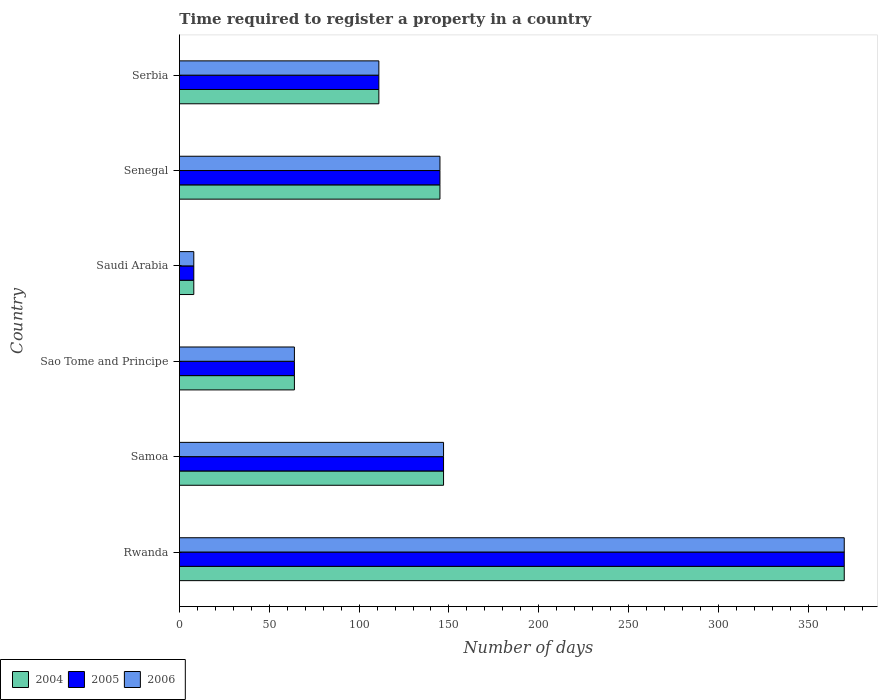Are the number of bars per tick equal to the number of legend labels?
Offer a very short reply. Yes. How many bars are there on the 6th tick from the top?
Provide a short and direct response. 3. How many bars are there on the 6th tick from the bottom?
Offer a terse response. 3. What is the label of the 5th group of bars from the top?
Keep it short and to the point. Samoa. Across all countries, what is the maximum number of days required to register a property in 2004?
Ensure brevity in your answer.  370. In which country was the number of days required to register a property in 2006 maximum?
Give a very brief answer. Rwanda. In which country was the number of days required to register a property in 2004 minimum?
Ensure brevity in your answer.  Saudi Arabia. What is the total number of days required to register a property in 2004 in the graph?
Your answer should be compact. 845. What is the difference between the number of days required to register a property in 2006 in Rwanda and that in Samoa?
Your answer should be very brief. 223. What is the difference between the number of days required to register a property in 2004 in Serbia and the number of days required to register a property in 2006 in Sao Tome and Principe?
Provide a succinct answer. 47. What is the average number of days required to register a property in 2004 per country?
Keep it short and to the point. 140.83. What is the difference between the number of days required to register a property in 2004 and number of days required to register a property in 2006 in Senegal?
Provide a short and direct response. 0. What is the ratio of the number of days required to register a property in 2005 in Saudi Arabia to that in Serbia?
Offer a terse response. 0.07. Is the number of days required to register a property in 2004 in Samoa less than that in Saudi Arabia?
Offer a terse response. No. What is the difference between the highest and the second highest number of days required to register a property in 2004?
Provide a short and direct response. 223. What is the difference between the highest and the lowest number of days required to register a property in 2004?
Offer a terse response. 362. In how many countries, is the number of days required to register a property in 2004 greater than the average number of days required to register a property in 2004 taken over all countries?
Provide a succinct answer. 3. Is the sum of the number of days required to register a property in 2004 in Rwanda and Saudi Arabia greater than the maximum number of days required to register a property in 2006 across all countries?
Make the answer very short. Yes. What does the 2nd bar from the top in Samoa represents?
Provide a short and direct response. 2005. What does the 2nd bar from the bottom in Saudi Arabia represents?
Give a very brief answer. 2005. How many bars are there?
Ensure brevity in your answer.  18. Are all the bars in the graph horizontal?
Give a very brief answer. Yes. What is the difference between two consecutive major ticks on the X-axis?
Your answer should be very brief. 50. Are the values on the major ticks of X-axis written in scientific E-notation?
Offer a terse response. No. Does the graph contain any zero values?
Offer a very short reply. No. Does the graph contain grids?
Keep it short and to the point. No. How are the legend labels stacked?
Keep it short and to the point. Horizontal. What is the title of the graph?
Give a very brief answer. Time required to register a property in a country. What is the label or title of the X-axis?
Provide a succinct answer. Number of days. What is the label or title of the Y-axis?
Give a very brief answer. Country. What is the Number of days in 2004 in Rwanda?
Your response must be concise. 370. What is the Number of days in 2005 in Rwanda?
Your answer should be compact. 370. What is the Number of days of 2006 in Rwanda?
Offer a terse response. 370. What is the Number of days of 2004 in Samoa?
Give a very brief answer. 147. What is the Number of days of 2005 in Samoa?
Give a very brief answer. 147. What is the Number of days of 2006 in Samoa?
Make the answer very short. 147. What is the Number of days of 2005 in Sao Tome and Principe?
Your response must be concise. 64. What is the Number of days of 2006 in Sao Tome and Principe?
Offer a very short reply. 64. What is the Number of days in 2005 in Saudi Arabia?
Provide a succinct answer. 8. What is the Number of days of 2004 in Senegal?
Give a very brief answer. 145. What is the Number of days in 2005 in Senegal?
Your response must be concise. 145. What is the Number of days of 2006 in Senegal?
Your answer should be very brief. 145. What is the Number of days of 2004 in Serbia?
Offer a terse response. 111. What is the Number of days in 2005 in Serbia?
Ensure brevity in your answer.  111. What is the Number of days of 2006 in Serbia?
Your response must be concise. 111. Across all countries, what is the maximum Number of days in 2004?
Make the answer very short. 370. Across all countries, what is the maximum Number of days in 2005?
Your answer should be compact. 370. Across all countries, what is the maximum Number of days in 2006?
Your answer should be very brief. 370. Across all countries, what is the minimum Number of days in 2004?
Keep it short and to the point. 8. Across all countries, what is the minimum Number of days of 2006?
Provide a short and direct response. 8. What is the total Number of days of 2004 in the graph?
Your response must be concise. 845. What is the total Number of days of 2005 in the graph?
Your response must be concise. 845. What is the total Number of days of 2006 in the graph?
Offer a terse response. 845. What is the difference between the Number of days in 2004 in Rwanda and that in Samoa?
Ensure brevity in your answer.  223. What is the difference between the Number of days in 2005 in Rwanda and that in Samoa?
Make the answer very short. 223. What is the difference between the Number of days in 2006 in Rwanda and that in Samoa?
Provide a succinct answer. 223. What is the difference between the Number of days in 2004 in Rwanda and that in Sao Tome and Principe?
Keep it short and to the point. 306. What is the difference between the Number of days of 2005 in Rwanda and that in Sao Tome and Principe?
Your answer should be compact. 306. What is the difference between the Number of days of 2006 in Rwanda and that in Sao Tome and Principe?
Provide a short and direct response. 306. What is the difference between the Number of days of 2004 in Rwanda and that in Saudi Arabia?
Offer a very short reply. 362. What is the difference between the Number of days in 2005 in Rwanda and that in Saudi Arabia?
Offer a terse response. 362. What is the difference between the Number of days in 2006 in Rwanda and that in Saudi Arabia?
Offer a very short reply. 362. What is the difference between the Number of days in 2004 in Rwanda and that in Senegal?
Make the answer very short. 225. What is the difference between the Number of days of 2005 in Rwanda and that in Senegal?
Make the answer very short. 225. What is the difference between the Number of days in 2006 in Rwanda and that in Senegal?
Your answer should be compact. 225. What is the difference between the Number of days of 2004 in Rwanda and that in Serbia?
Make the answer very short. 259. What is the difference between the Number of days in 2005 in Rwanda and that in Serbia?
Make the answer very short. 259. What is the difference between the Number of days of 2006 in Rwanda and that in Serbia?
Give a very brief answer. 259. What is the difference between the Number of days in 2004 in Samoa and that in Sao Tome and Principe?
Your answer should be compact. 83. What is the difference between the Number of days of 2004 in Samoa and that in Saudi Arabia?
Make the answer very short. 139. What is the difference between the Number of days in 2005 in Samoa and that in Saudi Arabia?
Ensure brevity in your answer.  139. What is the difference between the Number of days of 2006 in Samoa and that in Saudi Arabia?
Your answer should be compact. 139. What is the difference between the Number of days of 2004 in Samoa and that in Senegal?
Offer a terse response. 2. What is the difference between the Number of days of 2005 in Samoa and that in Senegal?
Ensure brevity in your answer.  2. What is the difference between the Number of days of 2006 in Samoa and that in Senegal?
Make the answer very short. 2. What is the difference between the Number of days of 2004 in Samoa and that in Serbia?
Ensure brevity in your answer.  36. What is the difference between the Number of days in 2005 in Samoa and that in Serbia?
Make the answer very short. 36. What is the difference between the Number of days in 2006 in Samoa and that in Serbia?
Your response must be concise. 36. What is the difference between the Number of days of 2004 in Sao Tome and Principe and that in Saudi Arabia?
Your response must be concise. 56. What is the difference between the Number of days in 2005 in Sao Tome and Principe and that in Saudi Arabia?
Your answer should be compact. 56. What is the difference between the Number of days of 2004 in Sao Tome and Principe and that in Senegal?
Give a very brief answer. -81. What is the difference between the Number of days of 2005 in Sao Tome and Principe and that in Senegal?
Make the answer very short. -81. What is the difference between the Number of days in 2006 in Sao Tome and Principe and that in Senegal?
Your answer should be compact. -81. What is the difference between the Number of days in 2004 in Sao Tome and Principe and that in Serbia?
Keep it short and to the point. -47. What is the difference between the Number of days in 2005 in Sao Tome and Principe and that in Serbia?
Offer a terse response. -47. What is the difference between the Number of days in 2006 in Sao Tome and Principe and that in Serbia?
Keep it short and to the point. -47. What is the difference between the Number of days of 2004 in Saudi Arabia and that in Senegal?
Provide a succinct answer. -137. What is the difference between the Number of days of 2005 in Saudi Arabia and that in Senegal?
Ensure brevity in your answer.  -137. What is the difference between the Number of days in 2006 in Saudi Arabia and that in Senegal?
Your answer should be compact. -137. What is the difference between the Number of days of 2004 in Saudi Arabia and that in Serbia?
Offer a terse response. -103. What is the difference between the Number of days in 2005 in Saudi Arabia and that in Serbia?
Give a very brief answer. -103. What is the difference between the Number of days in 2006 in Saudi Arabia and that in Serbia?
Offer a terse response. -103. What is the difference between the Number of days of 2004 in Rwanda and the Number of days of 2005 in Samoa?
Offer a terse response. 223. What is the difference between the Number of days of 2004 in Rwanda and the Number of days of 2006 in Samoa?
Provide a succinct answer. 223. What is the difference between the Number of days of 2005 in Rwanda and the Number of days of 2006 in Samoa?
Ensure brevity in your answer.  223. What is the difference between the Number of days of 2004 in Rwanda and the Number of days of 2005 in Sao Tome and Principe?
Your answer should be compact. 306. What is the difference between the Number of days in 2004 in Rwanda and the Number of days in 2006 in Sao Tome and Principe?
Ensure brevity in your answer.  306. What is the difference between the Number of days of 2005 in Rwanda and the Number of days of 2006 in Sao Tome and Principe?
Your answer should be very brief. 306. What is the difference between the Number of days in 2004 in Rwanda and the Number of days in 2005 in Saudi Arabia?
Keep it short and to the point. 362. What is the difference between the Number of days of 2004 in Rwanda and the Number of days of 2006 in Saudi Arabia?
Offer a terse response. 362. What is the difference between the Number of days of 2005 in Rwanda and the Number of days of 2006 in Saudi Arabia?
Offer a terse response. 362. What is the difference between the Number of days in 2004 in Rwanda and the Number of days in 2005 in Senegal?
Offer a very short reply. 225. What is the difference between the Number of days of 2004 in Rwanda and the Number of days of 2006 in Senegal?
Your response must be concise. 225. What is the difference between the Number of days of 2005 in Rwanda and the Number of days of 2006 in Senegal?
Offer a very short reply. 225. What is the difference between the Number of days of 2004 in Rwanda and the Number of days of 2005 in Serbia?
Offer a terse response. 259. What is the difference between the Number of days in 2004 in Rwanda and the Number of days in 2006 in Serbia?
Give a very brief answer. 259. What is the difference between the Number of days in 2005 in Rwanda and the Number of days in 2006 in Serbia?
Provide a succinct answer. 259. What is the difference between the Number of days in 2004 in Samoa and the Number of days in 2006 in Sao Tome and Principe?
Provide a succinct answer. 83. What is the difference between the Number of days of 2005 in Samoa and the Number of days of 2006 in Sao Tome and Principe?
Offer a very short reply. 83. What is the difference between the Number of days of 2004 in Samoa and the Number of days of 2005 in Saudi Arabia?
Your answer should be very brief. 139. What is the difference between the Number of days of 2004 in Samoa and the Number of days of 2006 in Saudi Arabia?
Ensure brevity in your answer.  139. What is the difference between the Number of days of 2005 in Samoa and the Number of days of 2006 in Saudi Arabia?
Make the answer very short. 139. What is the difference between the Number of days in 2004 in Samoa and the Number of days in 2006 in Senegal?
Provide a succinct answer. 2. What is the difference between the Number of days in 2005 in Samoa and the Number of days in 2006 in Senegal?
Your response must be concise. 2. What is the difference between the Number of days in 2004 in Samoa and the Number of days in 2005 in Serbia?
Keep it short and to the point. 36. What is the difference between the Number of days in 2004 in Samoa and the Number of days in 2006 in Serbia?
Give a very brief answer. 36. What is the difference between the Number of days of 2005 in Samoa and the Number of days of 2006 in Serbia?
Provide a succinct answer. 36. What is the difference between the Number of days in 2004 in Sao Tome and Principe and the Number of days in 2006 in Saudi Arabia?
Offer a terse response. 56. What is the difference between the Number of days of 2005 in Sao Tome and Principe and the Number of days of 2006 in Saudi Arabia?
Your answer should be compact. 56. What is the difference between the Number of days in 2004 in Sao Tome and Principe and the Number of days in 2005 in Senegal?
Your answer should be compact. -81. What is the difference between the Number of days of 2004 in Sao Tome and Principe and the Number of days of 2006 in Senegal?
Give a very brief answer. -81. What is the difference between the Number of days of 2005 in Sao Tome and Principe and the Number of days of 2006 in Senegal?
Keep it short and to the point. -81. What is the difference between the Number of days in 2004 in Sao Tome and Principe and the Number of days in 2005 in Serbia?
Provide a short and direct response. -47. What is the difference between the Number of days of 2004 in Sao Tome and Principe and the Number of days of 2006 in Serbia?
Offer a terse response. -47. What is the difference between the Number of days in 2005 in Sao Tome and Principe and the Number of days in 2006 in Serbia?
Provide a short and direct response. -47. What is the difference between the Number of days of 2004 in Saudi Arabia and the Number of days of 2005 in Senegal?
Ensure brevity in your answer.  -137. What is the difference between the Number of days in 2004 in Saudi Arabia and the Number of days in 2006 in Senegal?
Give a very brief answer. -137. What is the difference between the Number of days in 2005 in Saudi Arabia and the Number of days in 2006 in Senegal?
Keep it short and to the point. -137. What is the difference between the Number of days of 2004 in Saudi Arabia and the Number of days of 2005 in Serbia?
Your answer should be compact. -103. What is the difference between the Number of days in 2004 in Saudi Arabia and the Number of days in 2006 in Serbia?
Your response must be concise. -103. What is the difference between the Number of days in 2005 in Saudi Arabia and the Number of days in 2006 in Serbia?
Your answer should be very brief. -103. What is the difference between the Number of days of 2004 in Senegal and the Number of days of 2005 in Serbia?
Give a very brief answer. 34. What is the difference between the Number of days of 2004 in Senegal and the Number of days of 2006 in Serbia?
Ensure brevity in your answer.  34. What is the difference between the Number of days in 2005 in Senegal and the Number of days in 2006 in Serbia?
Ensure brevity in your answer.  34. What is the average Number of days of 2004 per country?
Give a very brief answer. 140.83. What is the average Number of days of 2005 per country?
Keep it short and to the point. 140.83. What is the average Number of days in 2006 per country?
Your response must be concise. 140.83. What is the difference between the Number of days in 2004 and Number of days in 2005 in Samoa?
Provide a succinct answer. 0. What is the difference between the Number of days in 2004 and Number of days in 2006 in Samoa?
Your response must be concise. 0. What is the difference between the Number of days of 2005 and Number of days of 2006 in Samoa?
Provide a succinct answer. 0. What is the difference between the Number of days in 2004 and Number of days in 2005 in Sao Tome and Principe?
Ensure brevity in your answer.  0. What is the difference between the Number of days of 2004 and Number of days of 2006 in Sao Tome and Principe?
Provide a short and direct response. 0. What is the difference between the Number of days of 2005 and Number of days of 2006 in Sao Tome and Principe?
Give a very brief answer. 0. What is the difference between the Number of days of 2004 and Number of days of 2005 in Saudi Arabia?
Provide a short and direct response. 0. What is the difference between the Number of days in 2004 and Number of days in 2006 in Saudi Arabia?
Give a very brief answer. 0. What is the difference between the Number of days of 2004 and Number of days of 2005 in Senegal?
Offer a very short reply. 0. What is the difference between the Number of days of 2005 and Number of days of 2006 in Serbia?
Keep it short and to the point. 0. What is the ratio of the Number of days in 2004 in Rwanda to that in Samoa?
Keep it short and to the point. 2.52. What is the ratio of the Number of days of 2005 in Rwanda to that in Samoa?
Give a very brief answer. 2.52. What is the ratio of the Number of days of 2006 in Rwanda to that in Samoa?
Your answer should be very brief. 2.52. What is the ratio of the Number of days of 2004 in Rwanda to that in Sao Tome and Principe?
Provide a succinct answer. 5.78. What is the ratio of the Number of days in 2005 in Rwanda to that in Sao Tome and Principe?
Your answer should be compact. 5.78. What is the ratio of the Number of days in 2006 in Rwanda to that in Sao Tome and Principe?
Make the answer very short. 5.78. What is the ratio of the Number of days of 2004 in Rwanda to that in Saudi Arabia?
Your answer should be compact. 46.25. What is the ratio of the Number of days in 2005 in Rwanda to that in Saudi Arabia?
Give a very brief answer. 46.25. What is the ratio of the Number of days in 2006 in Rwanda to that in Saudi Arabia?
Provide a short and direct response. 46.25. What is the ratio of the Number of days in 2004 in Rwanda to that in Senegal?
Make the answer very short. 2.55. What is the ratio of the Number of days of 2005 in Rwanda to that in Senegal?
Your answer should be compact. 2.55. What is the ratio of the Number of days in 2006 in Rwanda to that in Senegal?
Your answer should be very brief. 2.55. What is the ratio of the Number of days in 2004 in Rwanda to that in Serbia?
Make the answer very short. 3.33. What is the ratio of the Number of days in 2005 in Rwanda to that in Serbia?
Give a very brief answer. 3.33. What is the ratio of the Number of days of 2006 in Rwanda to that in Serbia?
Make the answer very short. 3.33. What is the ratio of the Number of days in 2004 in Samoa to that in Sao Tome and Principe?
Provide a succinct answer. 2.3. What is the ratio of the Number of days of 2005 in Samoa to that in Sao Tome and Principe?
Make the answer very short. 2.3. What is the ratio of the Number of days of 2006 in Samoa to that in Sao Tome and Principe?
Your response must be concise. 2.3. What is the ratio of the Number of days of 2004 in Samoa to that in Saudi Arabia?
Your answer should be compact. 18.38. What is the ratio of the Number of days in 2005 in Samoa to that in Saudi Arabia?
Offer a terse response. 18.38. What is the ratio of the Number of days of 2006 in Samoa to that in Saudi Arabia?
Offer a terse response. 18.38. What is the ratio of the Number of days in 2004 in Samoa to that in Senegal?
Provide a short and direct response. 1.01. What is the ratio of the Number of days of 2005 in Samoa to that in Senegal?
Give a very brief answer. 1.01. What is the ratio of the Number of days in 2006 in Samoa to that in Senegal?
Provide a short and direct response. 1.01. What is the ratio of the Number of days in 2004 in Samoa to that in Serbia?
Make the answer very short. 1.32. What is the ratio of the Number of days of 2005 in Samoa to that in Serbia?
Offer a very short reply. 1.32. What is the ratio of the Number of days in 2006 in Samoa to that in Serbia?
Your response must be concise. 1.32. What is the ratio of the Number of days in 2004 in Sao Tome and Principe to that in Saudi Arabia?
Your answer should be compact. 8. What is the ratio of the Number of days of 2005 in Sao Tome and Principe to that in Saudi Arabia?
Provide a short and direct response. 8. What is the ratio of the Number of days in 2006 in Sao Tome and Principe to that in Saudi Arabia?
Provide a short and direct response. 8. What is the ratio of the Number of days of 2004 in Sao Tome and Principe to that in Senegal?
Your answer should be very brief. 0.44. What is the ratio of the Number of days of 2005 in Sao Tome and Principe to that in Senegal?
Ensure brevity in your answer.  0.44. What is the ratio of the Number of days of 2006 in Sao Tome and Principe to that in Senegal?
Offer a terse response. 0.44. What is the ratio of the Number of days in 2004 in Sao Tome and Principe to that in Serbia?
Give a very brief answer. 0.58. What is the ratio of the Number of days in 2005 in Sao Tome and Principe to that in Serbia?
Your answer should be compact. 0.58. What is the ratio of the Number of days in 2006 in Sao Tome and Principe to that in Serbia?
Give a very brief answer. 0.58. What is the ratio of the Number of days in 2004 in Saudi Arabia to that in Senegal?
Your response must be concise. 0.06. What is the ratio of the Number of days of 2005 in Saudi Arabia to that in Senegal?
Your response must be concise. 0.06. What is the ratio of the Number of days of 2006 in Saudi Arabia to that in Senegal?
Ensure brevity in your answer.  0.06. What is the ratio of the Number of days in 2004 in Saudi Arabia to that in Serbia?
Give a very brief answer. 0.07. What is the ratio of the Number of days in 2005 in Saudi Arabia to that in Serbia?
Your response must be concise. 0.07. What is the ratio of the Number of days of 2006 in Saudi Arabia to that in Serbia?
Keep it short and to the point. 0.07. What is the ratio of the Number of days of 2004 in Senegal to that in Serbia?
Provide a succinct answer. 1.31. What is the ratio of the Number of days in 2005 in Senegal to that in Serbia?
Offer a terse response. 1.31. What is the ratio of the Number of days in 2006 in Senegal to that in Serbia?
Give a very brief answer. 1.31. What is the difference between the highest and the second highest Number of days of 2004?
Keep it short and to the point. 223. What is the difference between the highest and the second highest Number of days in 2005?
Offer a very short reply. 223. What is the difference between the highest and the second highest Number of days of 2006?
Offer a very short reply. 223. What is the difference between the highest and the lowest Number of days in 2004?
Keep it short and to the point. 362. What is the difference between the highest and the lowest Number of days of 2005?
Your answer should be very brief. 362. What is the difference between the highest and the lowest Number of days of 2006?
Offer a very short reply. 362. 